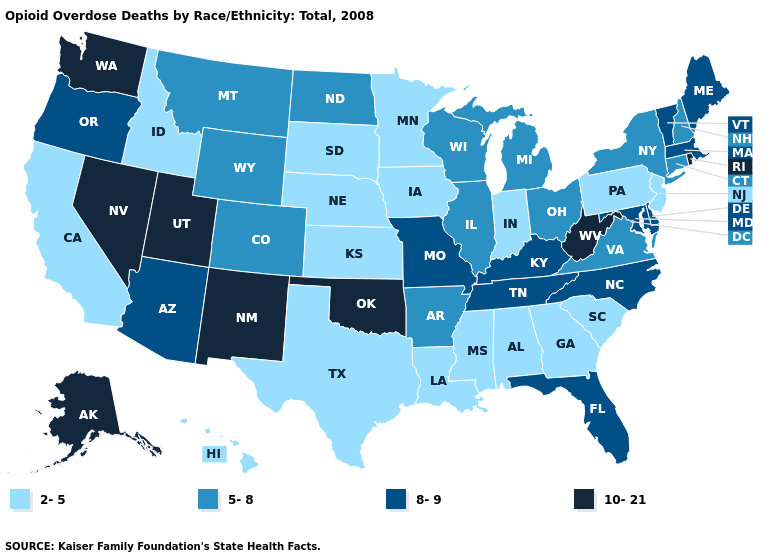Does Iowa have the highest value in the MidWest?
Quick response, please. No. Does Maine have a higher value than Texas?
Give a very brief answer. Yes. Does West Virginia have a higher value than Alaska?
Answer briefly. No. Name the states that have a value in the range 10-21?
Concise answer only. Alaska, Nevada, New Mexico, Oklahoma, Rhode Island, Utah, Washington, West Virginia. Name the states that have a value in the range 5-8?
Keep it brief. Arkansas, Colorado, Connecticut, Illinois, Michigan, Montana, New Hampshire, New York, North Dakota, Ohio, Virginia, Wisconsin, Wyoming. Among the states that border Louisiana , does Arkansas have the highest value?
Keep it brief. Yes. Name the states that have a value in the range 8-9?
Be succinct. Arizona, Delaware, Florida, Kentucky, Maine, Maryland, Massachusetts, Missouri, North Carolina, Oregon, Tennessee, Vermont. How many symbols are there in the legend?
Concise answer only. 4. What is the highest value in the USA?
Short answer required. 10-21. Does the first symbol in the legend represent the smallest category?
Short answer required. Yes. Does Missouri have the highest value in the MidWest?
Short answer required. Yes. What is the value of Montana?
Keep it brief. 5-8. Does New York have the lowest value in the Northeast?
Be succinct. No. What is the value of Minnesota?
Give a very brief answer. 2-5. Which states have the lowest value in the USA?
Write a very short answer. Alabama, California, Georgia, Hawaii, Idaho, Indiana, Iowa, Kansas, Louisiana, Minnesota, Mississippi, Nebraska, New Jersey, Pennsylvania, South Carolina, South Dakota, Texas. 